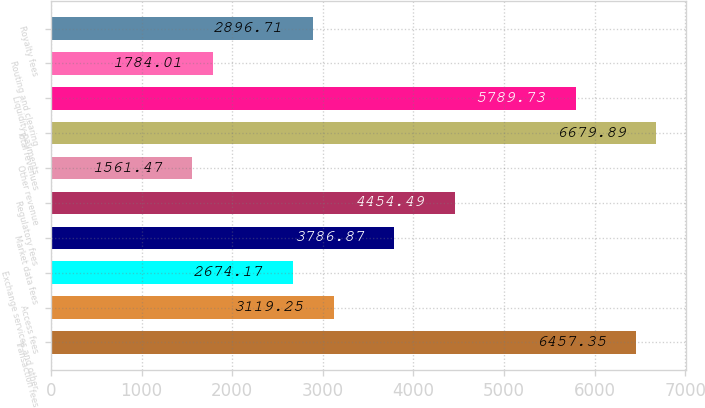<chart> <loc_0><loc_0><loc_500><loc_500><bar_chart><fcel>Transaction fees<fcel>Access fees<fcel>Exchange services and other<fcel>Market data fees<fcel>Regulatory fees<fcel>Other revenue<fcel>Total revenues<fcel>Liquidity payments<fcel>Routing and clearing<fcel>Royalty fees<nl><fcel>6457.35<fcel>3119.25<fcel>2674.17<fcel>3786.87<fcel>4454.49<fcel>1561.47<fcel>6679.89<fcel>5789.73<fcel>1784.01<fcel>2896.71<nl></chart> 